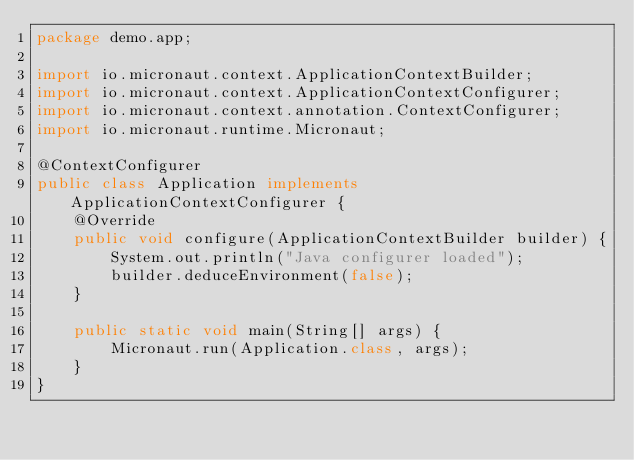<code> <loc_0><loc_0><loc_500><loc_500><_Java_>package demo.app;

import io.micronaut.context.ApplicationContextBuilder;
import io.micronaut.context.ApplicationContextConfigurer;
import io.micronaut.context.annotation.ContextConfigurer;
import io.micronaut.runtime.Micronaut;

@ContextConfigurer
public class Application implements ApplicationContextConfigurer {
    @Override
    public void configure(ApplicationContextBuilder builder) {
        System.out.println("Java configurer loaded");
        builder.deduceEnvironment(false);
    }

    public static void main(String[] args) {
        Micronaut.run(Application.class, args);
    }
}
</code> 